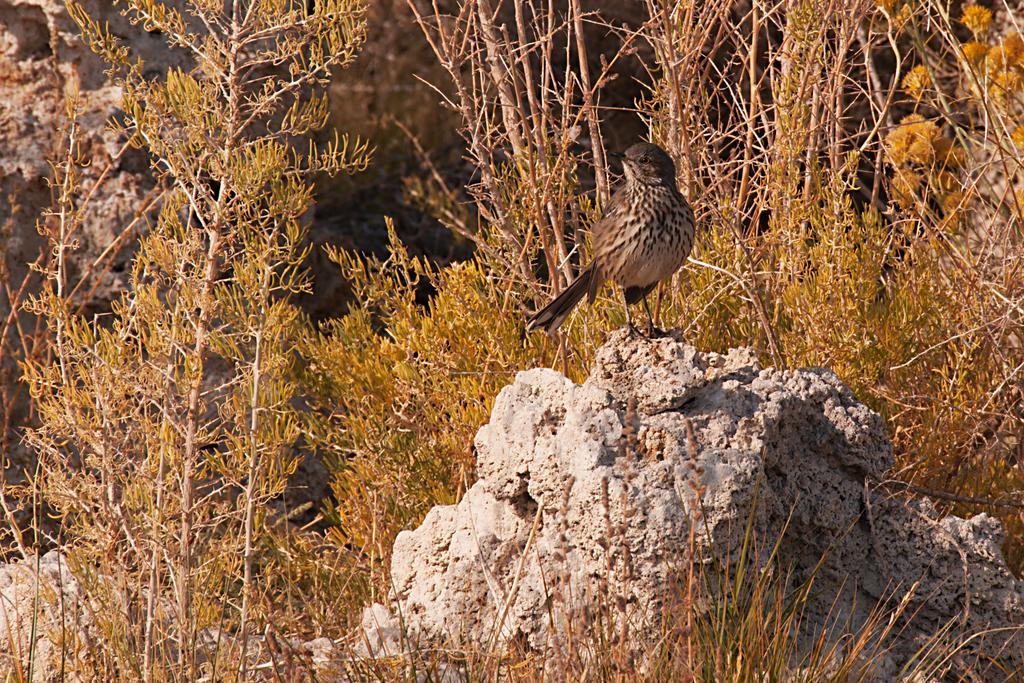In one or two sentences, can you explain what this image depicts? In this image I can see a bird which is brown and cream in color is on the rock. I can see few plants and the blurry background. 